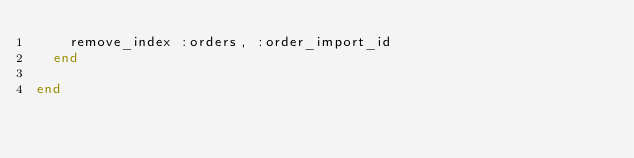Convert code to text. <code><loc_0><loc_0><loc_500><loc_500><_Ruby_>    remove_index :orders, :order_import_id
  end

end
</code> 